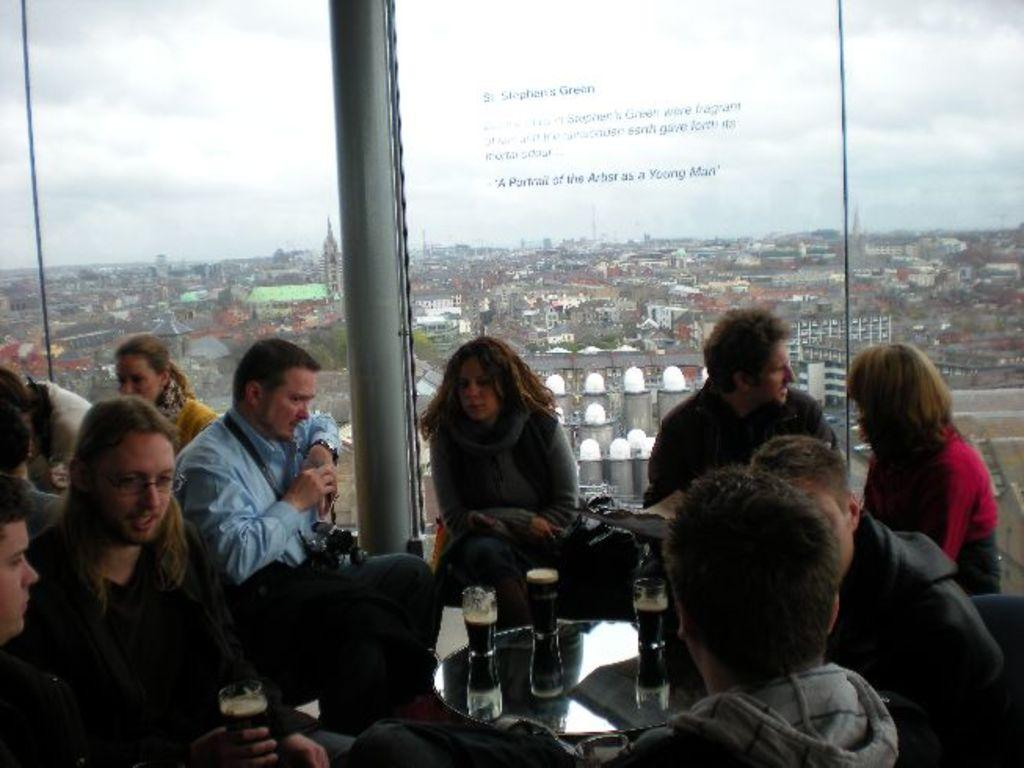How many people are in the image? There is a group of people in the image. What are the people doing in the image? The people are sitting in one place. What is in front of the people? There is a table in front of the people. What can be seen on the table? Glasses are placed on the table. What type of windows are visible in the image? There are glass windows visible in the image. What type of cakes are being served by the mom in the image? There is no mom present in the image, and no cakes are visible either. 